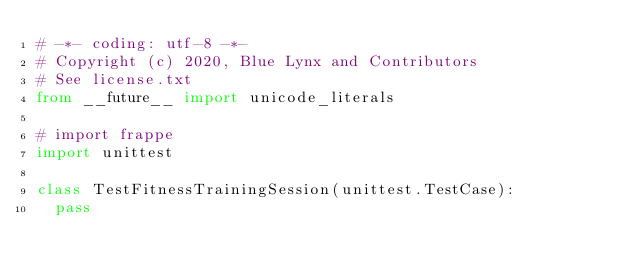Convert code to text. <code><loc_0><loc_0><loc_500><loc_500><_Python_># -*- coding: utf-8 -*-
# Copyright (c) 2020, Blue Lynx and Contributors
# See license.txt
from __future__ import unicode_literals

# import frappe
import unittest

class TestFitnessTrainingSession(unittest.TestCase):
	pass
</code> 